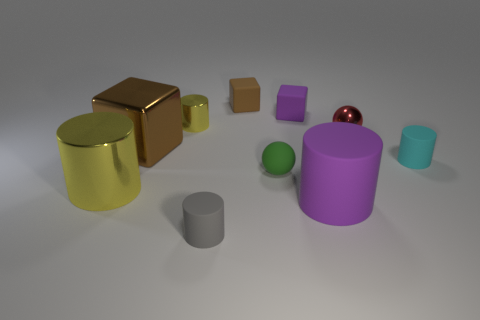Subtract 1 cylinders. How many cylinders are left? 4 Subtract all gray cylinders. How many cylinders are left? 4 Subtract all big metal cylinders. How many cylinders are left? 4 Subtract all red cylinders. Subtract all red balls. How many cylinders are left? 5 Subtract all blocks. How many objects are left? 7 Add 5 tiny cylinders. How many tiny cylinders are left? 8 Add 2 yellow blocks. How many yellow blocks exist? 2 Subtract 0 red cylinders. How many objects are left? 10 Subtract all red metallic objects. Subtract all small cyan rubber things. How many objects are left? 8 